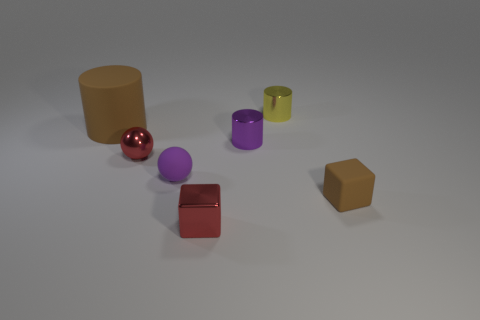What number of other objects are there of the same size as the purple metal cylinder?
Provide a short and direct response. 5. Do the cylinder that is to the left of the purple shiny cylinder and the tiny cube in front of the tiny brown thing have the same material?
Offer a terse response. No. How many tiny cubes are behind the tiny metallic block?
Provide a succinct answer. 1. How many brown things are either big rubber objects or tiny shiny balls?
Provide a short and direct response. 1. There is another cube that is the same size as the matte cube; what material is it?
Your answer should be compact. Metal. What is the shape of the matte thing that is both on the left side of the purple cylinder and to the right of the large brown rubber cylinder?
Make the answer very short. Sphere. What color is the other metallic cylinder that is the same size as the purple cylinder?
Ensure brevity in your answer.  Yellow. Is the size of the brown rubber thing left of the purple metal cylinder the same as the cube right of the tiny purple shiny thing?
Give a very brief answer. No. There is a thing that is behind the brown rubber object that is to the left of the red shiny thing that is to the right of the red ball; what size is it?
Offer a terse response. Small. What shape is the small metal thing that is in front of the red object that is behind the metallic block?
Your answer should be compact. Cube. 